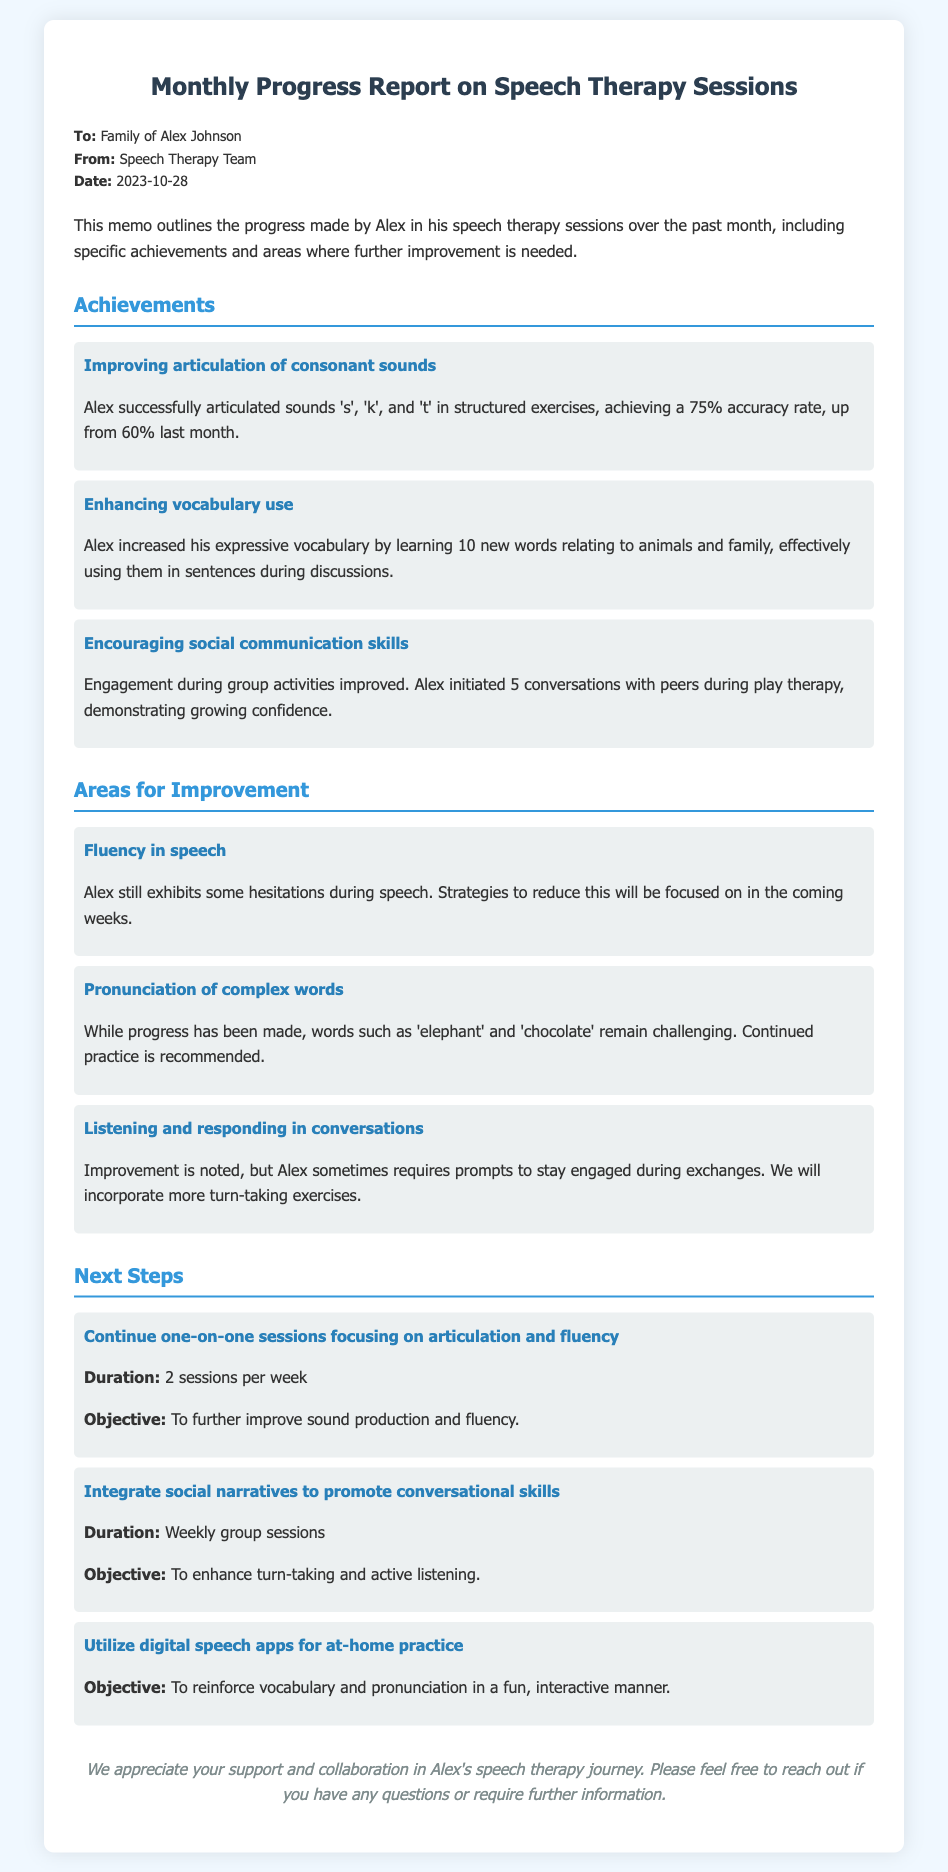What is the name of the child receiving therapy? The document mentions the child's name in the introduction as Alex Johnson.
Answer: Alex Johnson What date was the report created? The date is stated clearly in the header of the memo.
Answer: 2023-10-28 What is the accuracy rate of Alex’s articulation of consonant sounds? The accuracy rate is provided in the achievements section as part of the articulation progress.
Answer: 75% What is one of the areas that requires improvement? The document lists multiple areas for improvement as articulated in the corresponding section.
Answer: Fluency in speech How many new words did Alex learn relating to animals and family? The memo specifies the number of words learned in the achievements section.
Answer: 10 What strategy will be focused on to improve fluency in speech? The document mentions a focus on reducing hesitations which is an improvement strategy.
Answer: Strategies to reduce hesitation How many sessions per week are recommended for one-on-one therapy? This information is included under the next steps in the memo related to ongoing sessions.
Answer: 2 sessions per week What type of skills will social narratives aim to enhance? This is indicated in the objective for using social narratives mentioned in the next steps section.
Answer: Conversational skills Which app-related activity is suggested for at-home practice? The document specifically mentions utilizing digital speech apps in the next steps section.
Answer: Digital speech apps 